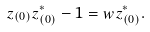Convert formula to latex. <formula><loc_0><loc_0><loc_500><loc_500>z _ { ( 0 ) } z _ { ( 0 ) } ^ { * } - 1 = w z _ { ( 0 ) } ^ { * } .</formula> 